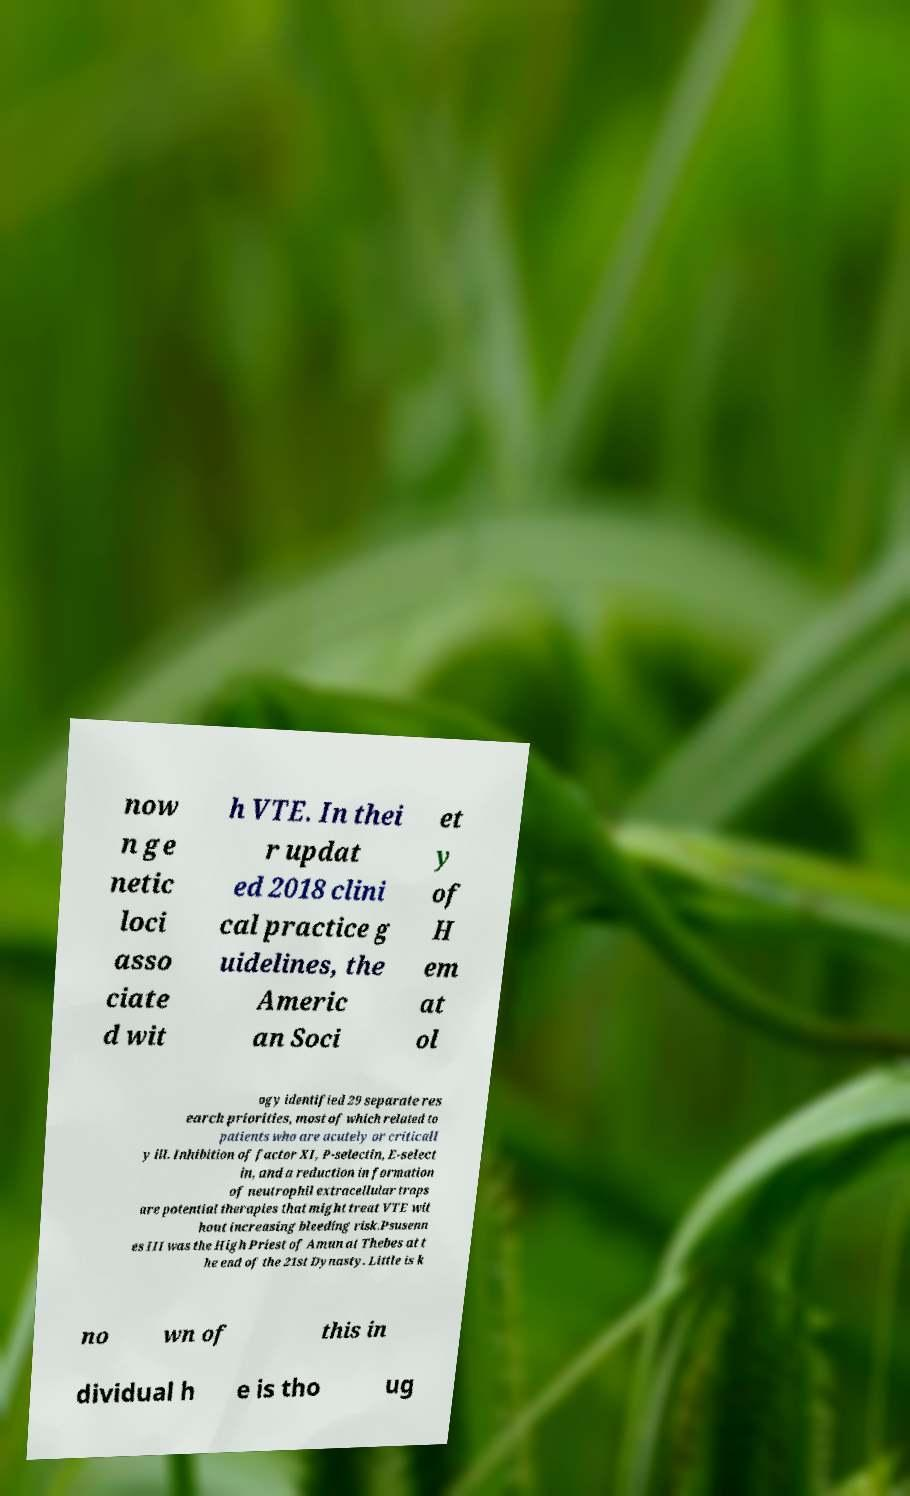Can you accurately transcribe the text from the provided image for me? now n ge netic loci asso ciate d wit h VTE. In thei r updat ed 2018 clini cal practice g uidelines, the Americ an Soci et y of H em at ol ogy identified 29 separate res earch priorities, most of which related to patients who are acutely or criticall y ill. Inhibition of factor XI, P-selectin, E-select in, and a reduction in formation of neutrophil extracellular traps are potential therapies that might treat VTE wit hout increasing bleeding risk.Psusenn es III was the High Priest of Amun at Thebes at t he end of the 21st Dynasty. Little is k no wn of this in dividual h e is tho ug 